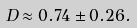<formula> <loc_0><loc_0><loc_500><loc_500>D \approx 0 . 7 4 \pm 0 . 2 6 .</formula> 